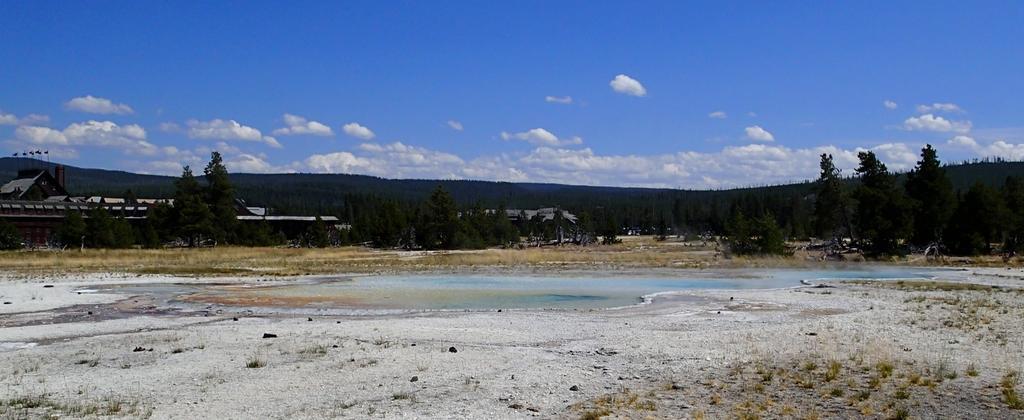Could you give a brief overview of what you see in this image? In this picture I can observe some water. There are some trees. On the left side I can observe some houses. In the background there are hills and a sky with some clouds. 